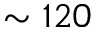Convert formula to latex. <formula><loc_0><loc_0><loc_500><loc_500>\sim 1 2 0</formula> 